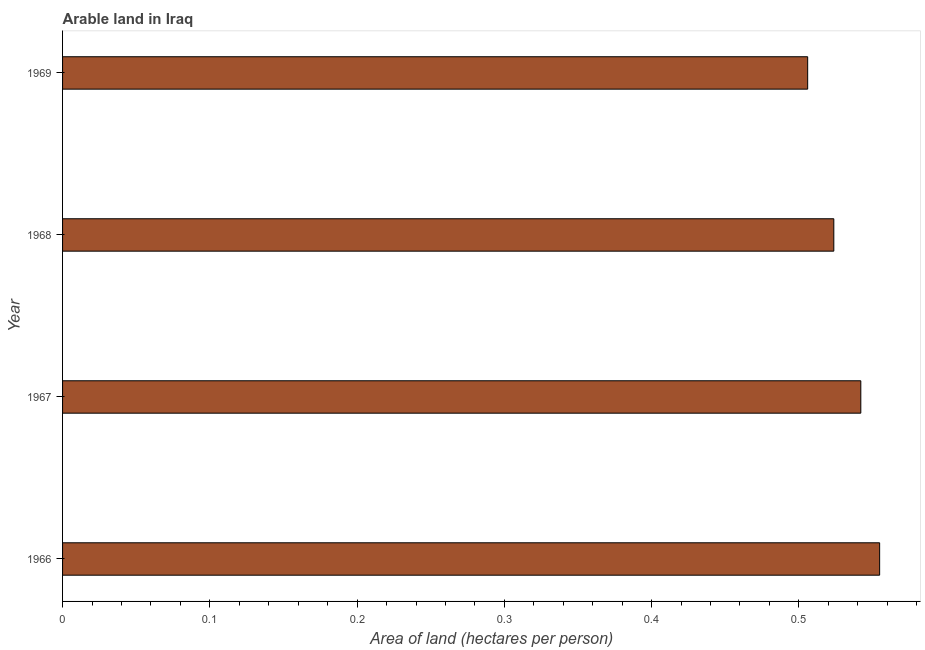Does the graph contain any zero values?
Your response must be concise. No. Does the graph contain grids?
Ensure brevity in your answer.  No. What is the title of the graph?
Make the answer very short. Arable land in Iraq. What is the label or title of the X-axis?
Give a very brief answer. Area of land (hectares per person). What is the label or title of the Y-axis?
Provide a succinct answer. Year. What is the area of arable land in 1967?
Make the answer very short. 0.54. Across all years, what is the maximum area of arable land?
Your response must be concise. 0.55. Across all years, what is the minimum area of arable land?
Your answer should be very brief. 0.51. In which year was the area of arable land maximum?
Give a very brief answer. 1966. In which year was the area of arable land minimum?
Make the answer very short. 1969. What is the sum of the area of arable land?
Provide a succinct answer. 2.13. What is the difference between the area of arable land in 1966 and 1968?
Keep it short and to the point. 0.03. What is the average area of arable land per year?
Provide a short and direct response. 0.53. What is the median area of arable land?
Provide a short and direct response. 0.53. In how many years, is the area of arable land greater than 0.4 hectares per person?
Give a very brief answer. 4. Do a majority of the years between 1967 and 1968 (inclusive) have area of arable land greater than 0.54 hectares per person?
Make the answer very short. No. Is the area of arable land in 1966 less than that in 1969?
Offer a terse response. No. Is the difference between the area of arable land in 1967 and 1969 greater than the difference between any two years?
Provide a succinct answer. No. What is the difference between the highest and the second highest area of arable land?
Your response must be concise. 0.01. Is the sum of the area of arable land in 1966 and 1969 greater than the maximum area of arable land across all years?
Offer a terse response. Yes. What is the difference between the highest and the lowest area of arable land?
Your answer should be compact. 0.05. How many bars are there?
Give a very brief answer. 4. What is the difference between two consecutive major ticks on the X-axis?
Your answer should be compact. 0.1. What is the Area of land (hectares per person) in 1966?
Your response must be concise. 0.55. What is the Area of land (hectares per person) of 1967?
Provide a succinct answer. 0.54. What is the Area of land (hectares per person) in 1968?
Keep it short and to the point. 0.52. What is the Area of land (hectares per person) of 1969?
Keep it short and to the point. 0.51. What is the difference between the Area of land (hectares per person) in 1966 and 1967?
Your response must be concise. 0.01. What is the difference between the Area of land (hectares per person) in 1966 and 1968?
Give a very brief answer. 0.03. What is the difference between the Area of land (hectares per person) in 1966 and 1969?
Offer a terse response. 0.05. What is the difference between the Area of land (hectares per person) in 1967 and 1968?
Your response must be concise. 0.02. What is the difference between the Area of land (hectares per person) in 1967 and 1969?
Offer a very short reply. 0.04. What is the difference between the Area of land (hectares per person) in 1968 and 1969?
Ensure brevity in your answer.  0.02. What is the ratio of the Area of land (hectares per person) in 1966 to that in 1968?
Ensure brevity in your answer.  1.06. What is the ratio of the Area of land (hectares per person) in 1966 to that in 1969?
Ensure brevity in your answer.  1.1. What is the ratio of the Area of land (hectares per person) in 1967 to that in 1968?
Offer a very short reply. 1.03. What is the ratio of the Area of land (hectares per person) in 1967 to that in 1969?
Provide a succinct answer. 1.07. What is the ratio of the Area of land (hectares per person) in 1968 to that in 1969?
Your answer should be very brief. 1.03. 